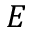Convert formula to latex. <formula><loc_0><loc_0><loc_500><loc_500>E</formula> 